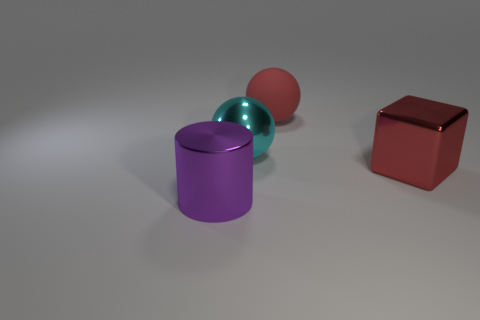Add 4 red cubes. How many objects exist? 8 Subtract all cubes. How many objects are left? 3 Add 3 tiny green rubber blocks. How many tiny green rubber blocks exist? 3 Subtract 0 gray cylinders. How many objects are left? 4 Subtract all cyan cubes. Subtract all big red metal things. How many objects are left? 3 Add 3 purple metal cylinders. How many purple metal cylinders are left? 4 